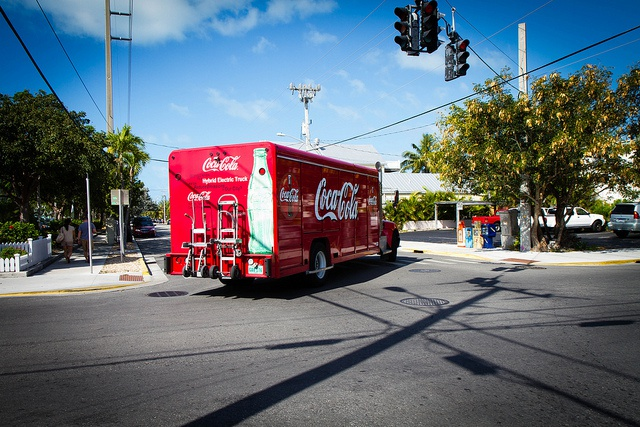Describe the objects in this image and their specific colors. I can see truck in blue, maroon, black, red, and white tones, bottle in blue, white, aquamarine, and turquoise tones, traffic light in blue, black, lightblue, navy, and gray tones, car in blue, black, and gray tones, and truck in blue, white, black, darkgray, and darkgreen tones in this image. 